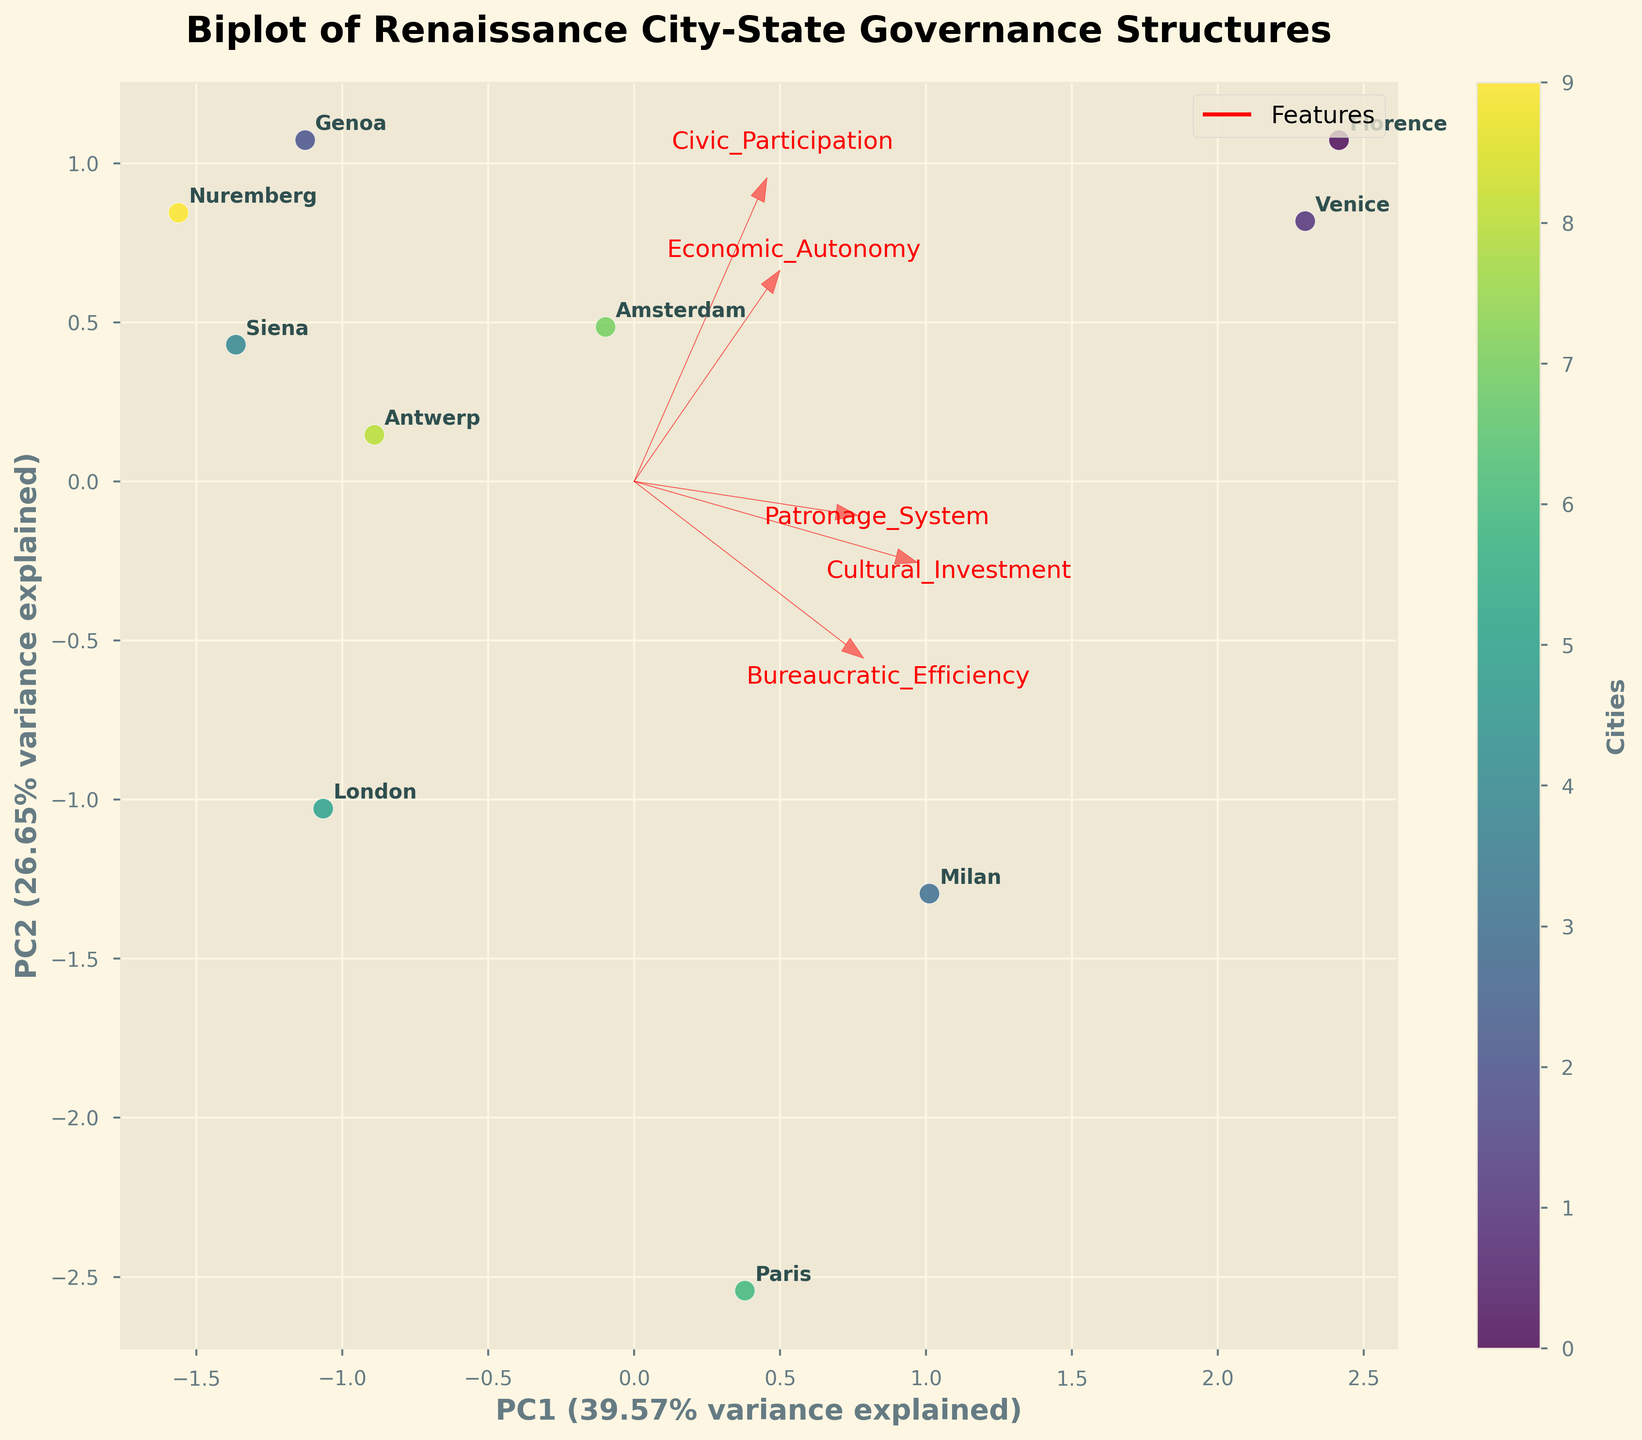How many cities are represented in the biplot? There are data points labeled for each city. By counting them, we can determine there are 10 different cities plotted.
Answer: 10 What is the title of the biplot? The title is located at the top of the plot. It reads "Biplot of Renaissance City-State Governance Structures".
Answer: Biplot of Renaissance City-State Governance Structures Which city is farthest to the right on the biplot? By examining the horizontal (x-axis) placement of each labeled data point, we can see which city is furthest to the right. "Florence" is positioned the farthest to the right.
Answer: Florence What is the angle between the vectors for "Civic_Participation" and "Economic_Autonomy"? The vectors representing "Civic_Participation" and "Economic_Autonomy" create an angle. By visually inspecting the orientation of these vectors, we can estimate the angle is slightly acute.
Answer: Slightly acute What feature has the highest loading on PC1? By examining the vectors, we compare their projections on the x-axis. "Economic_Autonomy" appears to have the longest projection on the x-axis.
Answer: Economic_Autonomy Which two cities are closest to each other in the biplot? "Venice" and "Florence" are positioned closest together on the plot. By assessing the proximity of the data points, we can determine these cities are nearest.
Answer: Venice and Florence How much variance is explained by PC1? The x-axis label provides the percentage of variance explained by PC1. It reads "PC1 (xx% variance explained)." By looking at this label, we see the exact percentage.
Answer: Approximately 48.3% Which feature appears to have minimal influence on PC2? By examining the vectors and their projections on the y-axis, "Patronage_System" has a notably shorter projection on the y-axis compared to other vectors.
Answer: Patronage_System Are "Paris" and "London" more similar or more different regarding their governance structures based on the biplot? Evaluating the distance between the points representing Paris and London on the biplot, they're relatively close, indicating similarity in governance structures.
Answer: More similar Are "Civic_Participation" and "Cultural_Investment" positively correlated? By examining the vectors' directions, both "Civic_Participation" and "Cultural_Investment" point in roughly the same direction, suggesting a positive correlation.
Answer: Yes 